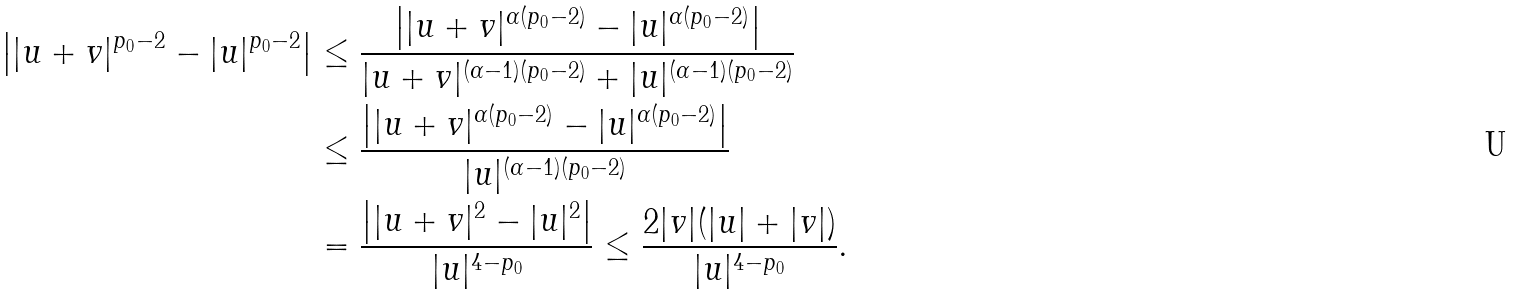<formula> <loc_0><loc_0><loc_500><loc_500>\left | | u + v | ^ { p _ { 0 } - 2 } - | u | ^ { p _ { 0 } - 2 } \right | & \leq \frac { \left | | u + v | ^ { \alpha ( p _ { 0 } - 2 ) } - | u | ^ { \alpha ( p _ { 0 } - 2 ) } \right | } { | u + v | ^ { ( \alpha - 1 ) ( p _ { 0 } - 2 ) } + | u | ^ { ( \alpha - 1 ) ( p _ { 0 } - 2 ) } } \\ & \leq \frac { \left | | u + v | ^ { \alpha ( p _ { 0 } - 2 ) } - | u | ^ { \alpha ( p _ { 0 } - 2 ) } \right | } { | u | ^ { ( \alpha - 1 ) ( p _ { 0 } - 2 ) } } \\ & = \frac { \left | | u + v | ^ { 2 } - | u | ^ { 2 } \right | } { | u | ^ { 4 - p _ { 0 } } } \leq \frac { 2 | v | ( | u | + | v | ) } { | u | ^ { 4 - p _ { 0 } } } .</formula> 